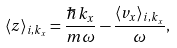Convert formula to latex. <formula><loc_0><loc_0><loc_500><loc_500>\langle z \rangle _ { i , k _ { x } } = \frac { \hbar { k } _ { x } } { m \omega } - \frac { \langle v _ { x } \rangle _ { i , k _ { x } } } { \omega } ,</formula> 